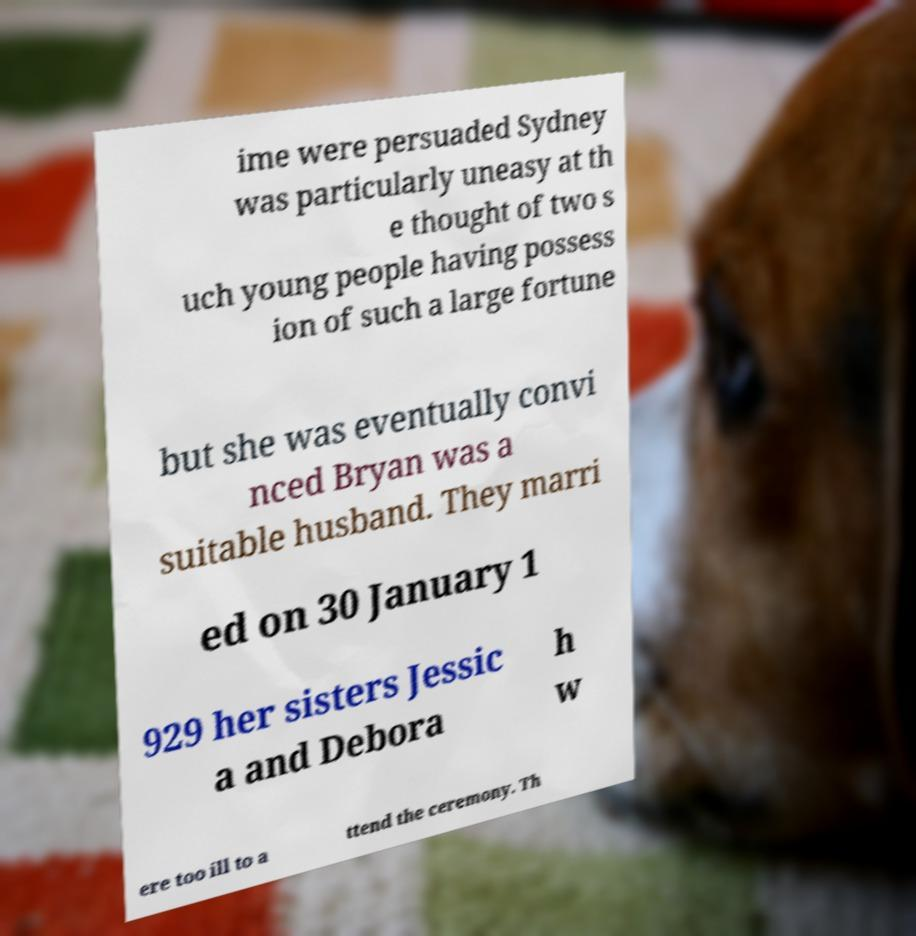There's text embedded in this image that I need extracted. Can you transcribe it verbatim? ime were persuaded Sydney was particularly uneasy at th e thought of two s uch young people having possess ion of such a large fortune but she was eventually convi nced Bryan was a suitable husband. They marri ed on 30 January 1 929 her sisters Jessic a and Debora h w ere too ill to a ttend the ceremony. Th 